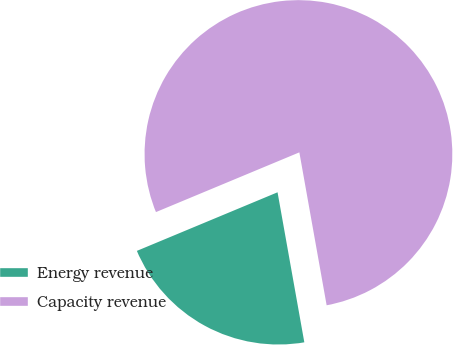Convert chart to OTSL. <chart><loc_0><loc_0><loc_500><loc_500><pie_chart><fcel>Energy revenue<fcel>Capacity revenue<nl><fcel>21.53%<fcel>78.47%<nl></chart> 